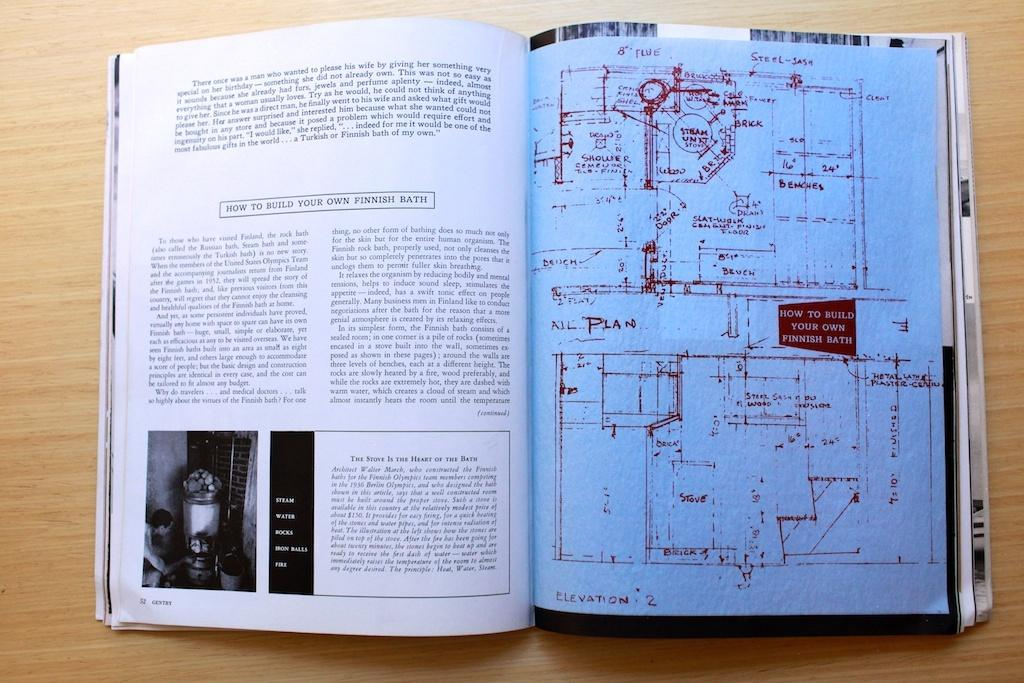<image>
Render a clear and concise summary of the photo. Diagram book of a blueprint or map of a finnish bath. 